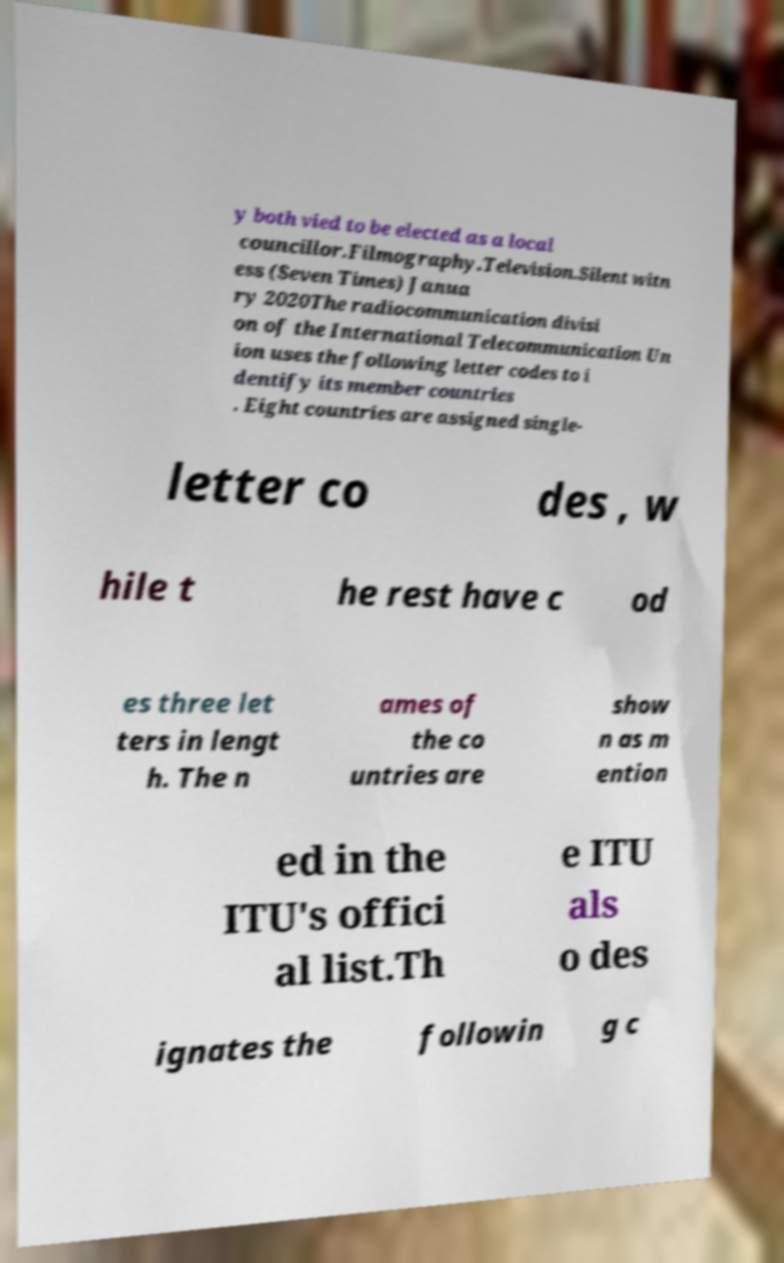Could you extract and type out the text from this image? y both vied to be elected as a local councillor.Filmography.Television.Silent witn ess (Seven Times) Janua ry 2020The radiocommunication divisi on of the International Telecommunication Un ion uses the following letter codes to i dentify its member countries . Eight countries are assigned single- letter co des , w hile t he rest have c od es three let ters in lengt h. The n ames of the co untries are show n as m ention ed in the ITU's offici al list.Th e ITU als o des ignates the followin g c 